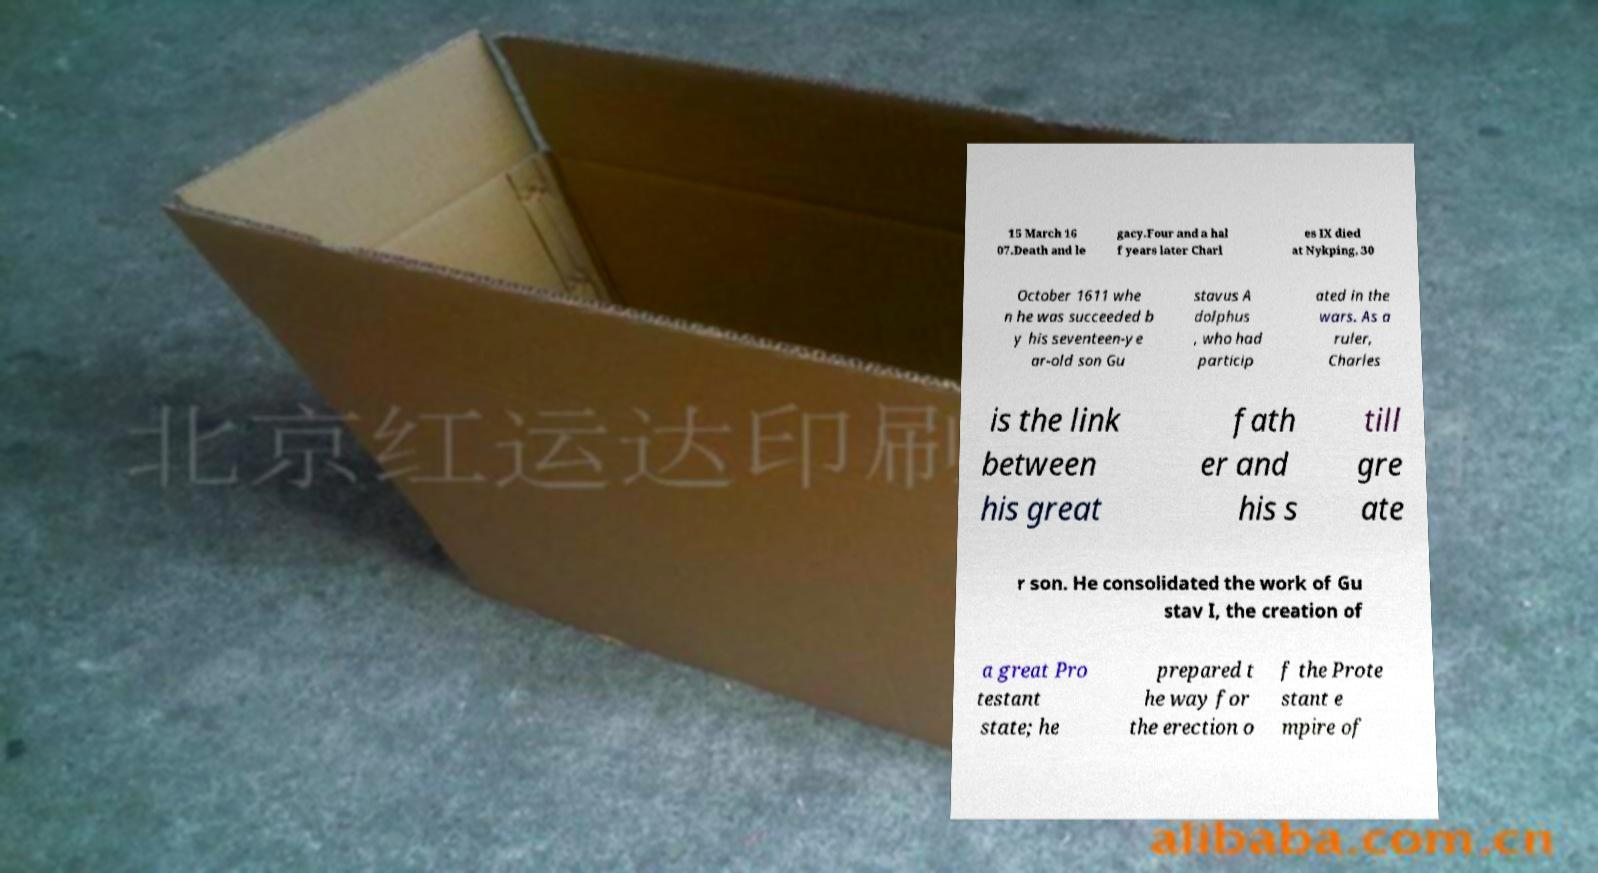There's text embedded in this image that I need extracted. Can you transcribe it verbatim? 15 March 16 07.Death and le gacy.Four and a hal f years later Charl es IX died at Nykping, 30 October 1611 whe n he was succeeded b y his seventeen-ye ar-old son Gu stavus A dolphus , who had particip ated in the wars. As a ruler, Charles is the link between his great fath er and his s till gre ate r son. He consolidated the work of Gu stav I, the creation of a great Pro testant state; he prepared t he way for the erection o f the Prote stant e mpire of 